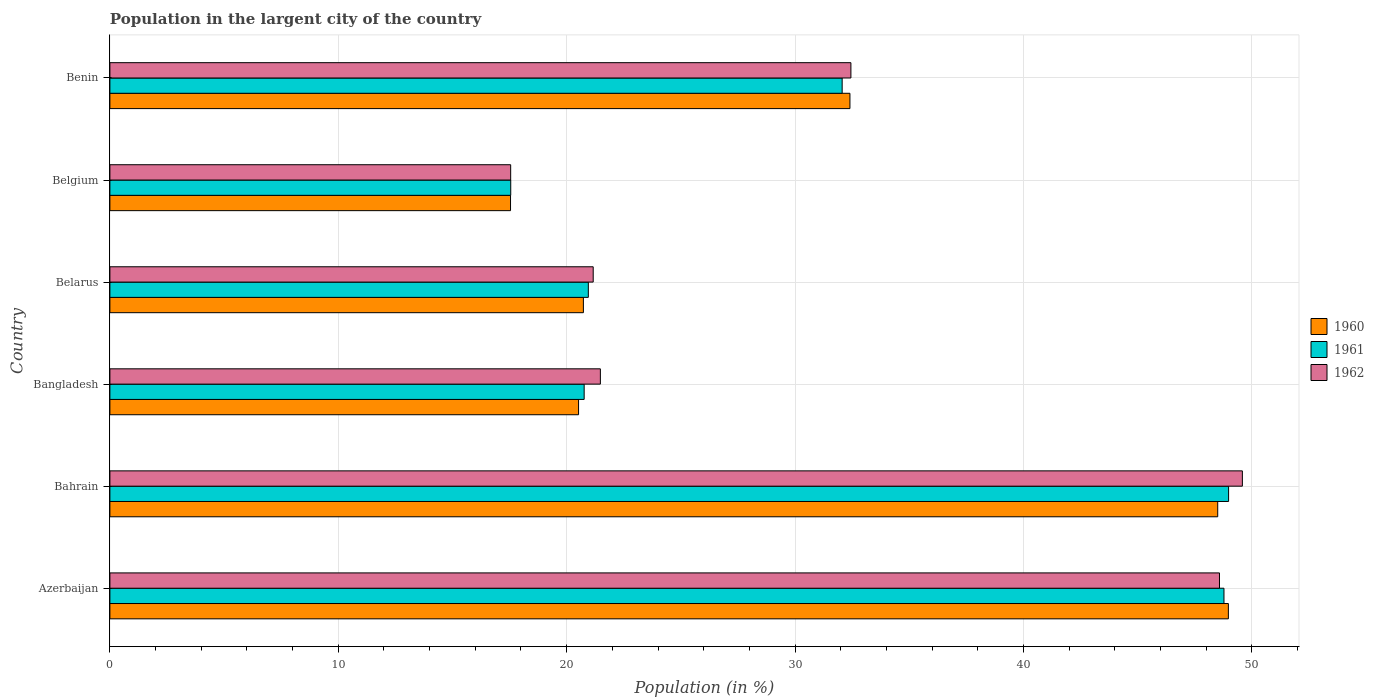How many different coloured bars are there?
Make the answer very short. 3. Are the number of bars on each tick of the Y-axis equal?
Your response must be concise. Yes. How many bars are there on the 6th tick from the top?
Give a very brief answer. 3. How many bars are there on the 2nd tick from the bottom?
Offer a very short reply. 3. What is the label of the 2nd group of bars from the top?
Give a very brief answer. Belgium. What is the percentage of population in the largent city in 1961 in Belgium?
Your response must be concise. 17.55. Across all countries, what is the maximum percentage of population in the largent city in 1961?
Your answer should be very brief. 48.98. Across all countries, what is the minimum percentage of population in the largent city in 1960?
Your answer should be compact. 17.54. In which country was the percentage of population in the largent city in 1961 maximum?
Offer a terse response. Bahrain. In which country was the percentage of population in the largent city in 1961 minimum?
Keep it short and to the point. Belgium. What is the total percentage of population in the largent city in 1960 in the graph?
Your response must be concise. 188.68. What is the difference between the percentage of population in the largent city in 1962 in Bahrain and that in Benin?
Keep it short and to the point. 17.14. What is the difference between the percentage of population in the largent city in 1960 in Benin and the percentage of population in the largent city in 1962 in Azerbaijan?
Keep it short and to the point. -16.18. What is the average percentage of population in the largent city in 1961 per country?
Ensure brevity in your answer.  31.52. What is the difference between the percentage of population in the largent city in 1961 and percentage of population in the largent city in 1962 in Belarus?
Offer a terse response. -0.21. What is the ratio of the percentage of population in the largent city in 1960 in Azerbaijan to that in Belarus?
Give a very brief answer. 2.36. Is the percentage of population in the largent city in 1962 in Azerbaijan less than that in Belarus?
Your answer should be compact. No. What is the difference between the highest and the second highest percentage of population in the largent city in 1962?
Your answer should be very brief. 1. What is the difference between the highest and the lowest percentage of population in the largent city in 1962?
Your answer should be very brief. 32.04. Is it the case that in every country, the sum of the percentage of population in the largent city in 1962 and percentage of population in the largent city in 1961 is greater than the percentage of population in the largent city in 1960?
Provide a short and direct response. Yes. Where does the legend appear in the graph?
Your answer should be compact. Center right. How many legend labels are there?
Offer a terse response. 3. How are the legend labels stacked?
Offer a terse response. Vertical. What is the title of the graph?
Provide a succinct answer. Population in the largent city of the country. Does "2001" appear as one of the legend labels in the graph?
Make the answer very short. No. What is the label or title of the X-axis?
Provide a short and direct response. Population (in %). What is the label or title of the Y-axis?
Make the answer very short. Country. What is the Population (in %) in 1960 in Azerbaijan?
Ensure brevity in your answer.  48.97. What is the Population (in %) of 1961 in Azerbaijan?
Your response must be concise. 48.78. What is the Population (in %) in 1962 in Azerbaijan?
Your answer should be very brief. 48.58. What is the Population (in %) in 1960 in Bahrain?
Keep it short and to the point. 48.51. What is the Population (in %) of 1961 in Bahrain?
Offer a very short reply. 48.98. What is the Population (in %) in 1962 in Bahrain?
Keep it short and to the point. 49.59. What is the Population (in %) in 1960 in Bangladesh?
Give a very brief answer. 20.52. What is the Population (in %) of 1961 in Bangladesh?
Your response must be concise. 20.77. What is the Population (in %) in 1962 in Bangladesh?
Your answer should be compact. 21.48. What is the Population (in %) of 1960 in Belarus?
Keep it short and to the point. 20.73. What is the Population (in %) of 1961 in Belarus?
Make the answer very short. 20.95. What is the Population (in %) of 1962 in Belarus?
Make the answer very short. 21.16. What is the Population (in %) of 1960 in Belgium?
Provide a short and direct response. 17.54. What is the Population (in %) in 1961 in Belgium?
Make the answer very short. 17.55. What is the Population (in %) in 1962 in Belgium?
Your answer should be very brief. 17.55. What is the Population (in %) in 1960 in Benin?
Your answer should be compact. 32.4. What is the Population (in %) in 1961 in Benin?
Your answer should be very brief. 32.06. What is the Population (in %) in 1962 in Benin?
Offer a terse response. 32.45. Across all countries, what is the maximum Population (in %) in 1960?
Your answer should be compact. 48.97. Across all countries, what is the maximum Population (in %) in 1961?
Ensure brevity in your answer.  48.98. Across all countries, what is the maximum Population (in %) of 1962?
Ensure brevity in your answer.  49.59. Across all countries, what is the minimum Population (in %) of 1960?
Your response must be concise. 17.54. Across all countries, what is the minimum Population (in %) in 1961?
Your response must be concise. 17.55. Across all countries, what is the minimum Population (in %) of 1962?
Ensure brevity in your answer.  17.55. What is the total Population (in %) of 1960 in the graph?
Provide a succinct answer. 188.68. What is the total Population (in %) of 1961 in the graph?
Offer a terse response. 189.09. What is the total Population (in %) of 1962 in the graph?
Provide a short and direct response. 190.8. What is the difference between the Population (in %) of 1960 in Azerbaijan and that in Bahrain?
Your answer should be compact. 0.47. What is the difference between the Population (in %) of 1961 in Azerbaijan and that in Bahrain?
Your answer should be compact. -0.2. What is the difference between the Population (in %) of 1962 in Azerbaijan and that in Bahrain?
Offer a very short reply. -1. What is the difference between the Population (in %) of 1960 in Azerbaijan and that in Bangladesh?
Give a very brief answer. 28.45. What is the difference between the Population (in %) of 1961 in Azerbaijan and that in Bangladesh?
Keep it short and to the point. 28.01. What is the difference between the Population (in %) of 1962 in Azerbaijan and that in Bangladesh?
Offer a very short reply. 27.11. What is the difference between the Population (in %) of 1960 in Azerbaijan and that in Belarus?
Your answer should be very brief. 28.24. What is the difference between the Population (in %) of 1961 in Azerbaijan and that in Belarus?
Keep it short and to the point. 27.83. What is the difference between the Population (in %) in 1962 in Azerbaijan and that in Belarus?
Give a very brief answer. 27.42. What is the difference between the Population (in %) in 1960 in Azerbaijan and that in Belgium?
Keep it short and to the point. 31.43. What is the difference between the Population (in %) of 1961 in Azerbaijan and that in Belgium?
Your response must be concise. 31.23. What is the difference between the Population (in %) of 1962 in Azerbaijan and that in Belgium?
Offer a very short reply. 31.04. What is the difference between the Population (in %) in 1960 in Azerbaijan and that in Benin?
Your response must be concise. 16.57. What is the difference between the Population (in %) in 1961 in Azerbaijan and that in Benin?
Your response must be concise. 16.72. What is the difference between the Population (in %) of 1962 in Azerbaijan and that in Benin?
Your response must be concise. 16.14. What is the difference between the Population (in %) of 1960 in Bahrain and that in Bangladesh?
Keep it short and to the point. 27.99. What is the difference between the Population (in %) in 1961 in Bahrain and that in Bangladesh?
Make the answer very short. 28.22. What is the difference between the Population (in %) of 1962 in Bahrain and that in Bangladesh?
Your response must be concise. 28.11. What is the difference between the Population (in %) in 1960 in Bahrain and that in Belarus?
Provide a succinct answer. 27.77. What is the difference between the Population (in %) in 1961 in Bahrain and that in Belarus?
Offer a terse response. 28.03. What is the difference between the Population (in %) in 1962 in Bahrain and that in Belarus?
Your response must be concise. 28.42. What is the difference between the Population (in %) in 1960 in Bahrain and that in Belgium?
Provide a succinct answer. 30.96. What is the difference between the Population (in %) in 1961 in Bahrain and that in Belgium?
Provide a succinct answer. 31.43. What is the difference between the Population (in %) of 1962 in Bahrain and that in Belgium?
Keep it short and to the point. 32.04. What is the difference between the Population (in %) of 1960 in Bahrain and that in Benin?
Provide a short and direct response. 16.1. What is the difference between the Population (in %) of 1961 in Bahrain and that in Benin?
Provide a short and direct response. 16.92. What is the difference between the Population (in %) in 1962 in Bahrain and that in Benin?
Your response must be concise. 17.14. What is the difference between the Population (in %) of 1960 in Bangladesh and that in Belarus?
Make the answer very short. -0.21. What is the difference between the Population (in %) in 1961 in Bangladesh and that in Belarus?
Your answer should be compact. -0.18. What is the difference between the Population (in %) in 1962 in Bangladesh and that in Belarus?
Ensure brevity in your answer.  0.31. What is the difference between the Population (in %) in 1960 in Bangladesh and that in Belgium?
Provide a succinct answer. 2.98. What is the difference between the Population (in %) in 1961 in Bangladesh and that in Belgium?
Give a very brief answer. 3.22. What is the difference between the Population (in %) of 1962 in Bangladesh and that in Belgium?
Your answer should be compact. 3.93. What is the difference between the Population (in %) of 1960 in Bangladesh and that in Benin?
Keep it short and to the point. -11.88. What is the difference between the Population (in %) in 1961 in Bangladesh and that in Benin?
Provide a short and direct response. -11.3. What is the difference between the Population (in %) in 1962 in Bangladesh and that in Benin?
Keep it short and to the point. -10.97. What is the difference between the Population (in %) of 1960 in Belarus and that in Belgium?
Ensure brevity in your answer.  3.19. What is the difference between the Population (in %) of 1961 in Belarus and that in Belgium?
Provide a succinct answer. 3.4. What is the difference between the Population (in %) in 1962 in Belarus and that in Belgium?
Make the answer very short. 3.61. What is the difference between the Population (in %) of 1960 in Belarus and that in Benin?
Your answer should be very brief. -11.67. What is the difference between the Population (in %) of 1961 in Belarus and that in Benin?
Keep it short and to the point. -11.11. What is the difference between the Population (in %) in 1962 in Belarus and that in Benin?
Give a very brief answer. -11.28. What is the difference between the Population (in %) of 1960 in Belgium and that in Benin?
Your response must be concise. -14.86. What is the difference between the Population (in %) in 1961 in Belgium and that in Benin?
Keep it short and to the point. -14.51. What is the difference between the Population (in %) in 1962 in Belgium and that in Benin?
Offer a very short reply. -14.9. What is the difference between the Population (in %) of 1960 in Azerbaijan and the Population (in %) of 1961 in Bahrain?
Your answer should be very brief. -0.01. What is the difference between the Population (in %) in 1960 in Azerbaijan and the Population (in %) in 1962 in Bahrain?
Keep it short and to the point. -0.61. What is the difference between the Population (in %) in 1961 in Azerbaijan and the Population (in %) in 1962 in Bahrain?
Provide a succinct answer. -0.81. What is the difference between the Population (in %) of 1960 in Azerbaijan and the Population (in %) of 1961 in Bangladesh?
Ensure brevity in your answer.  28.21. What is the difference between the Population (in %) of 1960 in Azerbaijan and the Population (in %) of 1962 in Bangladesh?
Your answer should be very brief. 27.5. What is the difference between the Population (in %) of 1961 in Azerbaijan and the Population (in %) of 1962 in Bangladesh?
Provide a short and direct response. 27.3. What is the difference between the Population (in %) of 1960 in Azerbaijan and the Population (in %) of 1961 in Belarus?
Make the answer very short. 28.02. What is the difference between the Population (in %) of 1960 in Azerbaijan and the Population (in %) of 1962 in Belarus?
Give a very brief answer. 27.81. What is the difference between the Population (in %) of 1961 in Azerbaijan and the Population (in %) of 1962 in Belarus?
Provide a short and direct response. 27.62. What is the difference between the Population (in %) in 1960 in Azerbaijan and the Population (in %) in 1961 in Belgium?
Make the answer very short. 31.42. What is the difference between the Population (in %) in 1960 in Azerbaijan and the Population (in %) in 1962 in Belgium?
Your answer should be compact. 31.42. What is the difference between the Population (in %) in 1961 in Azerbaijan and the Population (in %) in 1962 in Belgium?
Your response must be concise. 31.23. What is the difference between the Population (in %) in 1960 in Azerbaijan and the Population (in %) in 1961 in Benin?
Give a very brief answer. 16.91. What is the difference between the Population (in %) of 1960 in Azerbaijan and the Population (in %) of 1962 in Benin?
Your response must be concise. 16.53. What is the difference between the Population (in %) in 1961 in Azerbaijan and the Population (in %) in 1962 in Benin?
Provide a short and direct response. 16.33. What is the difference between the Population (in %) of 1960 in Bahrain and the Population (in %) of 1961 in Bangladesh?
Your response must be concise. 27.74. What is the difference between the Population (in %) of 1960 in Bahrain and the Population (in %) of 1962 in Bangladesh?
Give a very brief answer. 27.03. What is the difference between the Population (in %) of 1961 in Bahrain and the Population (in %) of 1962 in Bangladesh?
Provide a short and direct response. 27.51. What is the difference between the Population (in %) of 1960 in Bahrain and the Population (in %) of 1961 in Belarus?
Offer a very short reply. 27.56. What is the difference between the Population (in %) in 1960 in Bahrain and the Population (in %) in 1962 in Belarus?
Give a very brief answer. 27.34. What is the difference between the Population (in %) in 1961 in Bahrain and the Population (in %) in 1962 in Belarus?
Keep it short and to the point. 27.82. What is the difference between the Population (in %) in 1960 in Bahrain and the Population (in %) in 1961 in Belgium?
Keep it short and to the point. 30.96. What is the difference between the Population (in %) of 1960 in Bahrain and the Population (in %) of 1962 in Belgium?
Ensure brevity in your answer.  30.96. What is the difference between the Population (in %) in 1961 in Bahrain and the Population (in %) in 1962 in Belgium?
Your response must be concise. 31.43. What is the difference between the Population (in %) of 1960 in Bahrain and the Population (in %) of 1961 in Benin?
Offer a terse response. 16.44. What is the difference between the Population (in %) of 1960 in Bahrain and the Population (in %) of 1962 in Benin?
Provide a succinct answer. 16.06. What is the difference between the Population (in %) of 1961 in Bahrain and the Population (in %) of 1962 in Benin?
Offer a terse response. 16.54. What is the difference between the Population (in %) in 1960 in Bangladesh and the Population (in %) in 1961 in Belarus?
Keep it short and to the point. -0.43. What is the difference between the Population (in %) in 1960 in Bangladesh and the Population (in %) in 1962 in Belarus?
Give a very brief answer. -0.64. What is the difference between the Population (in %) in 1961 in Bangladesh and the Population (in %) in 1962 in Belarus?
Your response must be concise. -0.4. What is the difference between the Population (in %) of 1960 in Bangladesh and the Population (in %) of 1961 in Belgium?
Offer a very short reply. 2.97. What is the difference between the Population (in %) of 1960 in Bangladesh and the Population (in %) of 1962 in Belgium?
Keep it short and to the point. 2.97. What is the difference between the Population (in %) in 1961 in Bangladesh and the Population (in %) in 1962 in Belgium?
Provide a short and direct response. 3.22. What is the difference between the Population (in %) in 1960 in Bangladesh and the Population (in %) in 1961 in Benin?
Provide a succinct answer. -11.54. What is the difference between the Population (in %) in 1960 in Bangladesh and the Population (in %) in 1962 in Benin?
Offer a terse response. -11.92. What is the difference between the Population (in %) in 1961 in Bangladesh and the Population (in %) in 1962 in Benin?
Keep it short and to the point. -11.68. What is the difference between the Population (in %) of 1960 in Belarus and the Population (in %) of 1961 in Belgium?
Your answer should be compact. 3.18. What is the difference between the Population (in %) of 1960 in Belarus and the Population (in %) of 1962 in Belgium?
Ensure brevity in your answer.  3.18. What is the difference between the Population (in %) of 1961 in Belarus and the Population (in %) of 1962 in Belgium?
Keep it short and to the point. 3.4. What is the difference between the Population (in %) in 1960 in Belarus and the Population (in %) in 1961 in Benin?
Provide a succinct answer. -11.33. What is the difference between the Population (in %) in 1960 in Belarus and the Population (in %) in 1962 in Benin?
Provide a succinct answer. -11.71. What is the difference between the Population (in %) of 1961 in Belarus and the Population (in %) of 1962 in Benin?
Your answer should be compact. -11.5. What is the difference between the Population (in %) in 1960 in Belgium and the Population (in %) in 1961 in Benin?
Offer a terse response. -14.52. What is the difference between the Population (in %) of 1960 in Belgium and the Population (in %) of 1962 in Benin?
Provide a succinct answer. -14.9. What is the difference between the Population (in %) of 1961 in Belgium and the Population (in %) of 1962 in Benin?
Your answer should be very brief. -14.89. What is the average Population (in %) in 1960 per country?
Offer a terse response. 31.45. What is the average Population (in %) in 1961 per country?
Your answer should be compact. 31.52. What is the average Population (in %) in 1962 per country?
Your response must be concise. 31.8. What is the difference between the Population (in %) in 1960 and Population (in %) in 1961 in Azerbaijan?
Your answer should be very brief. 0.19. What is the difference between the Population (in %) in 1960 and Population (in %) in 1962 in Azerbaijan?
Your response must be concise. 0.39. What is the difference between the Population (in %) in 1961 and Population (in %) in 1962 in Azerbaijan?
Keep it short and to the point. 0.2. What is the difference between the Population (in %) in 1960 and Population (in %) in 1961 in Bahrain?
Your answer should be very brief. -0.48. What is the difference between the Population (in %) in 1960 and Population (in %) in 1962 in Bahrain?
Offer a very short reply. -1.08. What is the difference between the Population (in %) of 1961 and Population (in %) of 1962 in Bahrain?
Provide a short and direct response. -0.6. What is the difference between the Population (in %) of 1960 and Population (in %) of 1961 in Bangladesh?
Offer a very short reply. -0.24. What is the difference between the Population (in %) of 1960 and Population (in %) of 1962 in Bangladesh?
Offer a very short reply. -0.95. What is the difference between the Population (in %) in 1961 and Population (in %) in 1962 in Bangladesh?
Your response must be concise. -0.71. What is the difference between the Population (in %) in 1960 and Population (in %) in 1961 in Belarus?
Your answer should be compact. -0.22. What is the difference between the Population (in %) of 1960 and Population (in %) of 1962 in Belarus?
Offer a very short reply. -0.43. What is the difference between the Population (in %) of 1961 and Population (in %) of 1962 in Belarus?
Your answer should be compact. -0.21. What is the difference between the Population (in %) of 1960 and Population (in %) of 1961 in Belgium?
Give a very brief answer. -0.01. What is the difference between the Population (in %) in 1960 and Population (in %) in 1962 in Belgium?
Offer a very short reply. -0.01. What is the difference between the Population (in %) of 1961 and Population (in %) of 1962 in Belgium?
Your response must be concise. 0. What is the difference between the Population (in %) of 1960 and Population (in %) of 1961 in Benin?
Ensure brevity in your answer.  0.34. What is the difference between the Population (in %) in 1960 and Population (in %) in 1962 in Benin?
Your response must be concise. -0.04. What is the difference between the Population (in %) of 1961 and Population (in %) of 1962 in Benin?
Your answer should be compact. -0.38. What is the ratio of the Population (in %) of 1960 in Azerbaijan to that in Bahrain?
Offer a terse response. 1.01. What is the ratio of the Population (in %) of 1962 in Azerbaijan to that in Bahrain?
Offer a terse response. 0.98. What is the ratio of the Population (in %) of 1960 in Azerbaijan to that in Bangladesh?
Your answer should be compact. 2.39. What is the ratio of the Population (in %) in 1961 in Azerbaijan to that in Bangladesh?
Provide a short and direct response. 2.35. What is the ratio of the Population (in %) in 1962 in Azerbaijan to that in Bangladesh?
Keep it short and to the point. 2.26. What is the ratio of the Population (in %) of 1960 in Azerbaijan to that in Belarus?
Provide a short and direct response. 2.36. What is the ratio of the Population (in %) of 1961 in Azerbaijan to that in Belarus?
Your response must be concise. 2.33. What is the ratio of the Population (in %) of 1962 in Azerbaijan to that in Belarus?
Offer a terse response. 2.3. What is the ratio of the Population (in %) of 1960 in Azerbaijan to that in Belgium?
Ensure brevity in your answer.  2.79. What is the ratio of the Population (in %) of 1961 in Azerbaijan to that in Belgium?
Keep it short and to the point. 2.78. What is the ratio of the Population (in %) of 1962 in Azerbaijan to that in Belgium?
Give a very brief answer. 2.77. What is the ratio of the Population (in %) in 1960 in Azerbaijan to that in Benin?
Make the answer very short. 1.51. What is the ratio of the Population (in %) of 1961 in Azerbaijan to that in Benin?
Provide a succinct answer. 1.52. What is the ratio of the Population (in %) of 1962 in Azerbaijan to that in Benin?
Your answer should be very brief. 1.5. What is the ratio of the Population (in %) in 1960 in Bahrain to that in Bangladesh?
Keep it short and to the point. 2.36. What is the ratio of the Population (in %) of 1961 in Bahrain to that in Bangladesh?
Keep it short and to the point. 2.36. What is the ratio of the Population (in %) of 1962 in Bahrain to that in Bangladesh?
Ensure brevity in your answer.  2.31. What is the ratio of the Population (in %) of 1960 in Bahrain to that in Belarus?
Provide a short and direct response. 2.34. What is the ratio of the Population (in %) in 1961 in Bahrain to that in Belarus?
Provide a succinct answer. 2.34. What is the ratio of the Population (in %) of 1962 in Bahrain to that in Belarus?
Your answer should be compact. 2.34. What is the ratio of the Population (in %) of 1960 in Bahrain to that in Belgium?
Your answer should be compact. 2.77. What is the ratio of the Population (in %) of 1961 in Bahrain to that in Belgium?
Provide a short and direct response. 2.79. What is the ratio of the Population (in %) of 1962 in Bahrain to that in Belgium?
Give a very brief answer. 2.83. What is the ratio of the Population (in %) in 1960 in Bahrain to that in Benin?
Provide a short and direct response. 1.5. What is the ratio of the Population (in %) in 1961 in Bahrain to that in Benin?
Keep it short and to the point. 1.53. What is the ratio of the Population (in %) in 1962 in Bahrain to that in Benin?
Provide a short and direct response. 1.53. What is the ratio of the Population (in %) in 1960 in Bangladesh to that in Belarus?
Keep it short and to the point. 0.99. What is the ratio of the Population (in %) in 1962 in Bangladesh to that in Belarus?
Ensure brevity in your answer.  1.01. What is the ratio of the Population (in %) of 1960 in Bangladesh to that in Belgium?
Keep it short and to the point. 1.17. What is the ratio of the Population (in %) of 1961 in Bangladesh to that in Belgium?
Offer a very short reply. 1.18. What is the ratio of the Population (in %) in 1962 in Bangladesh to that in Belgium?
Provide a succinct answer. 1.22. What is the ratio of the Population (in %) of 1960 in Bangladesh to that in Benin?
Your answer should be very brief. 0.63. What is the ratio of the Population (in %) in 1961 in Bangladesh to that in Benin?
Offer a terse response. 0.65. What is the ratio of the Population (in %) of 1962 in Bangladesh to that in Benin?
Provide a short and direct response. 0.66. What is the ratio of the Population (in %) in 1960 in Belarus to that in Belgium?
Ensure brevity in your answer.  1.18. What is the ratio of the Population (in %) in 1961 in Belarus to that in Belgium?
Keep it short and to the point. 1.19. What is the ratio of the Population (in %) in 1962 in Belarus to that in Belgium?
Give a very brief answer. 1.21. What is the ratio of the Population (in %) in 1960 in Belarus to that in Benin?
Your answer should be very brief. 0.64. What is the ratio of the Population (in %) of 1961 in Belarus to that in Benin?
Make the answer very short. 0.65. What is the ratio of the Population (in %) in 1962 in Belarus to that in Benin?
Your answer should be compact. 0.65. What is the ratio of the Population (in %) in 1960 in Belgium to that in Benin?
Offer a very short reply. 0.54. What is the ratio of the Population (in %) of 1961 in Belgium to that in Benin?
Keep it short and to the point. 0.55. What is the ratio of the Population (in %) in 1962 in Belgium to that in Benin?
Provide a succinct answer. 0.54. What is the difference between the highest and the second highest Population (in %) of 1960?
Offer a terse response. 0.47. What is the difference between the highest and the second highest Population (in %) in 1961?
Your response must be concise. 0.2. What is the difference between the highest and the lowest Population (in %) in 1960?
Your answer should be compact. 31.43. What is the difference between the highest and the lowest Population (in %) of 1961?
Keep it short and to the point. 31.43. What is the difference between the highest and the lowest Population (in %) in 1962?
Ensure brevity in your answer.  32.04. 